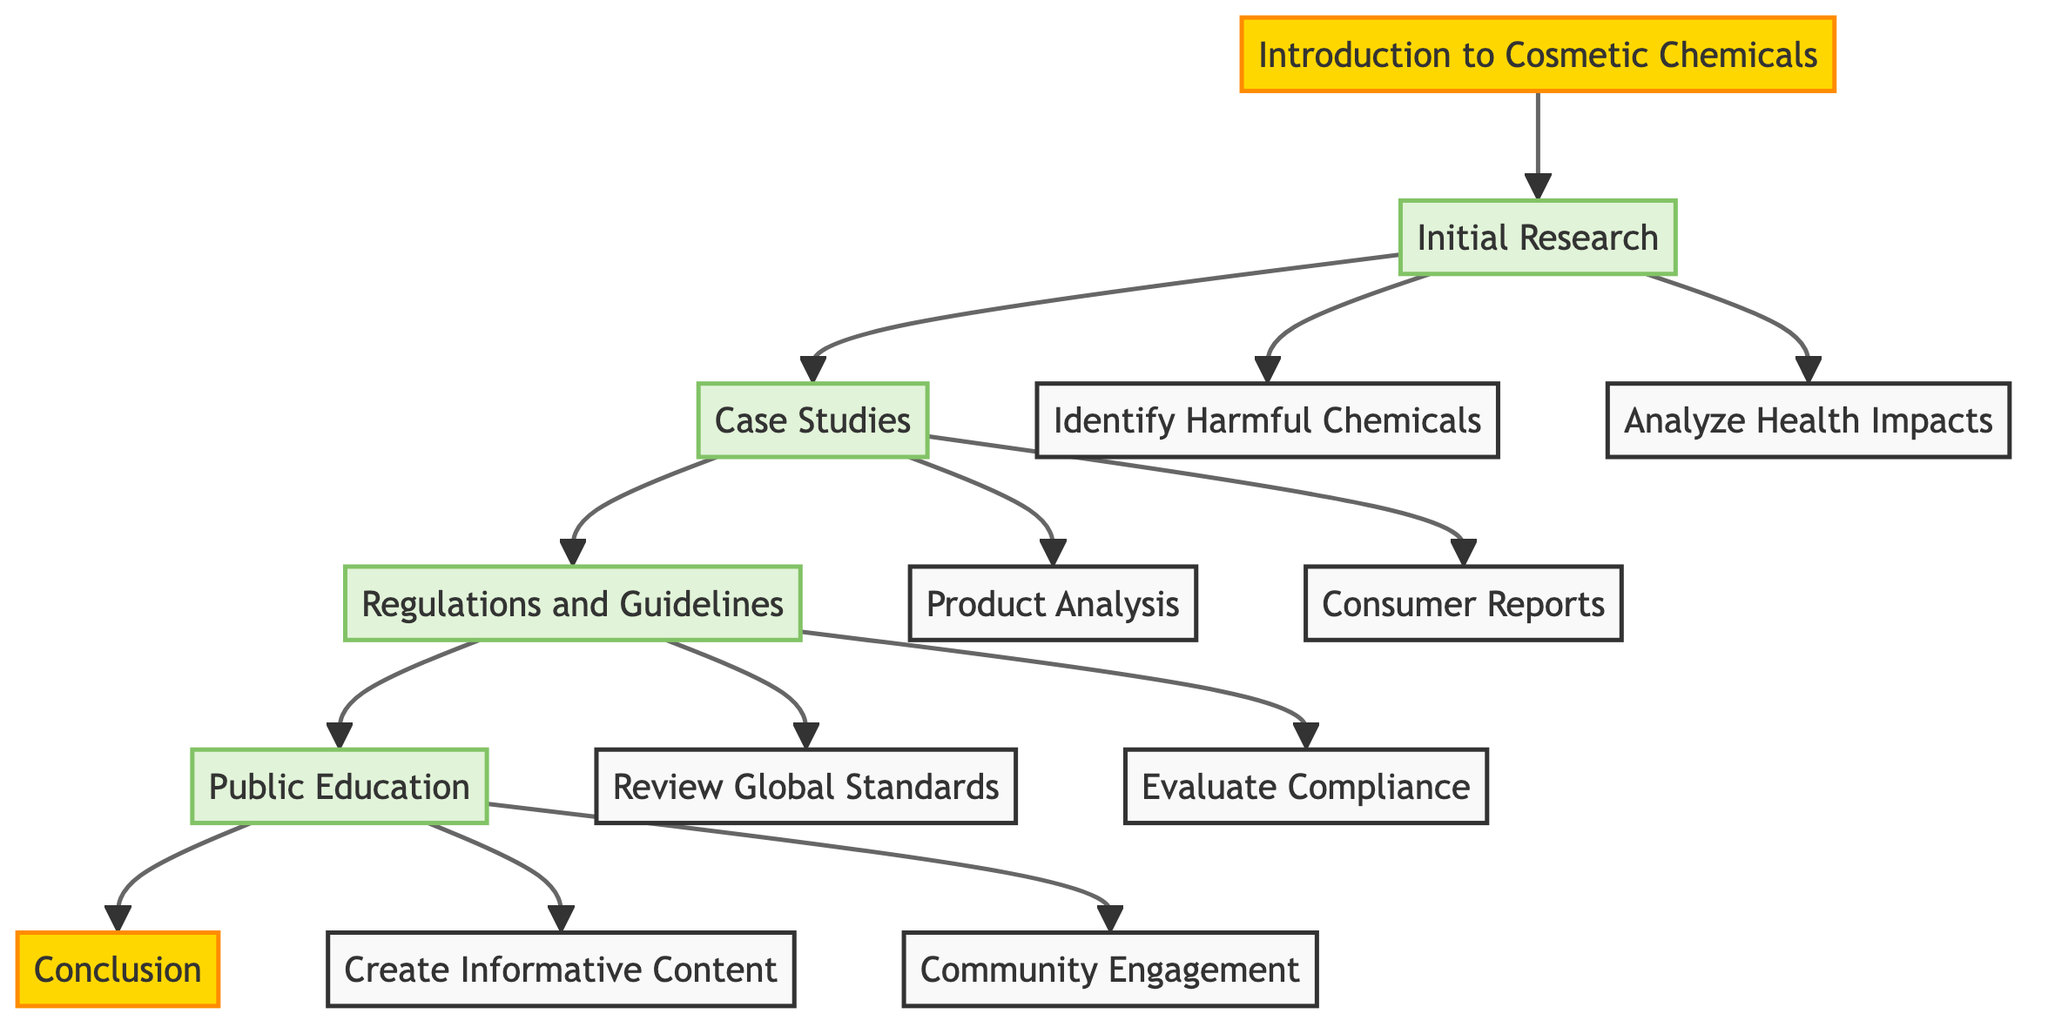What is the title of the clinical pathway? The title is stated at the top of the diagram and indicates the main focus of the pathway, which is "Introduction to Cosmetic Chemicals."
Answer: Introduction to Cosmetic Chemicals What is the first step in the Initial Research? Looking at the diagram, the first step that branches from "Initial Research" is labeled "Identify Harmful Chemicals."
Answer: Identify Harmful Chemicals How many total main sections are there in the pathway? Counting from the diagram, there are five main sections, starting from "Introduction" and ending with "Conclusion."
Answer: Five What are the two steps under Case Studies? By examining the "Case Studies" section of the diagram, the steps listed are "Product Analysis" and "Consumer Reports."
Answer: Product Analysis, Consumer Reports Which step follows Regulations and Guidelines? Referring to the directional flow in the diagram, the step that follows "Regulations and Guidelines" is "Public Education."
Answer: Public Education What are the final step and the milestone of this clinical pathway? The last step mentioned is "Conclusion," and it is categorized as a milestone along with "Introduction."
Answer: Conclusion Which two regulations are reviewed in the Regulations and Guidelines section? The diagram indicates that under "Regulations and Guidelines," the steps include "Review Global Standards" and "Evaluate Compliance."
Answer: Review Global Standards, Evaluate Compliance What is the focus of the Public Education section? The "Public Education" section aims to inform the public, as indicated by the steps "Create Informative Content" and "Community Engagement."
Answer: Informing the public How does the initial research contribute to the understanding of cosmetic chemicals? The "Initial Research" section is essential as it lays groundwork by identifying harmful chemicals and analyzing their health impacts, forming a foundation for the entire pathway.
Answer: Lays groundwork for understanding 